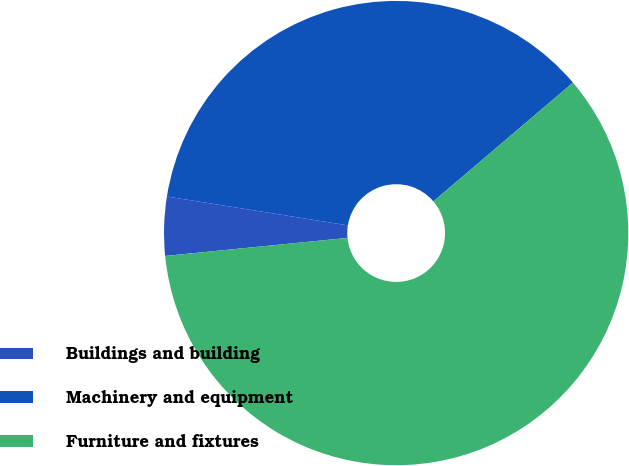Convert chart. <chart><loc_0><loc_0><loc_500><loc_500><pie_chart><fcel>Buildings and building<fcel>Machinery and equipment<fcel>Furniture and fixtures<nl><fcel>4.09%<fcel>36.26%<fcel>59.65%<nl></chart> 